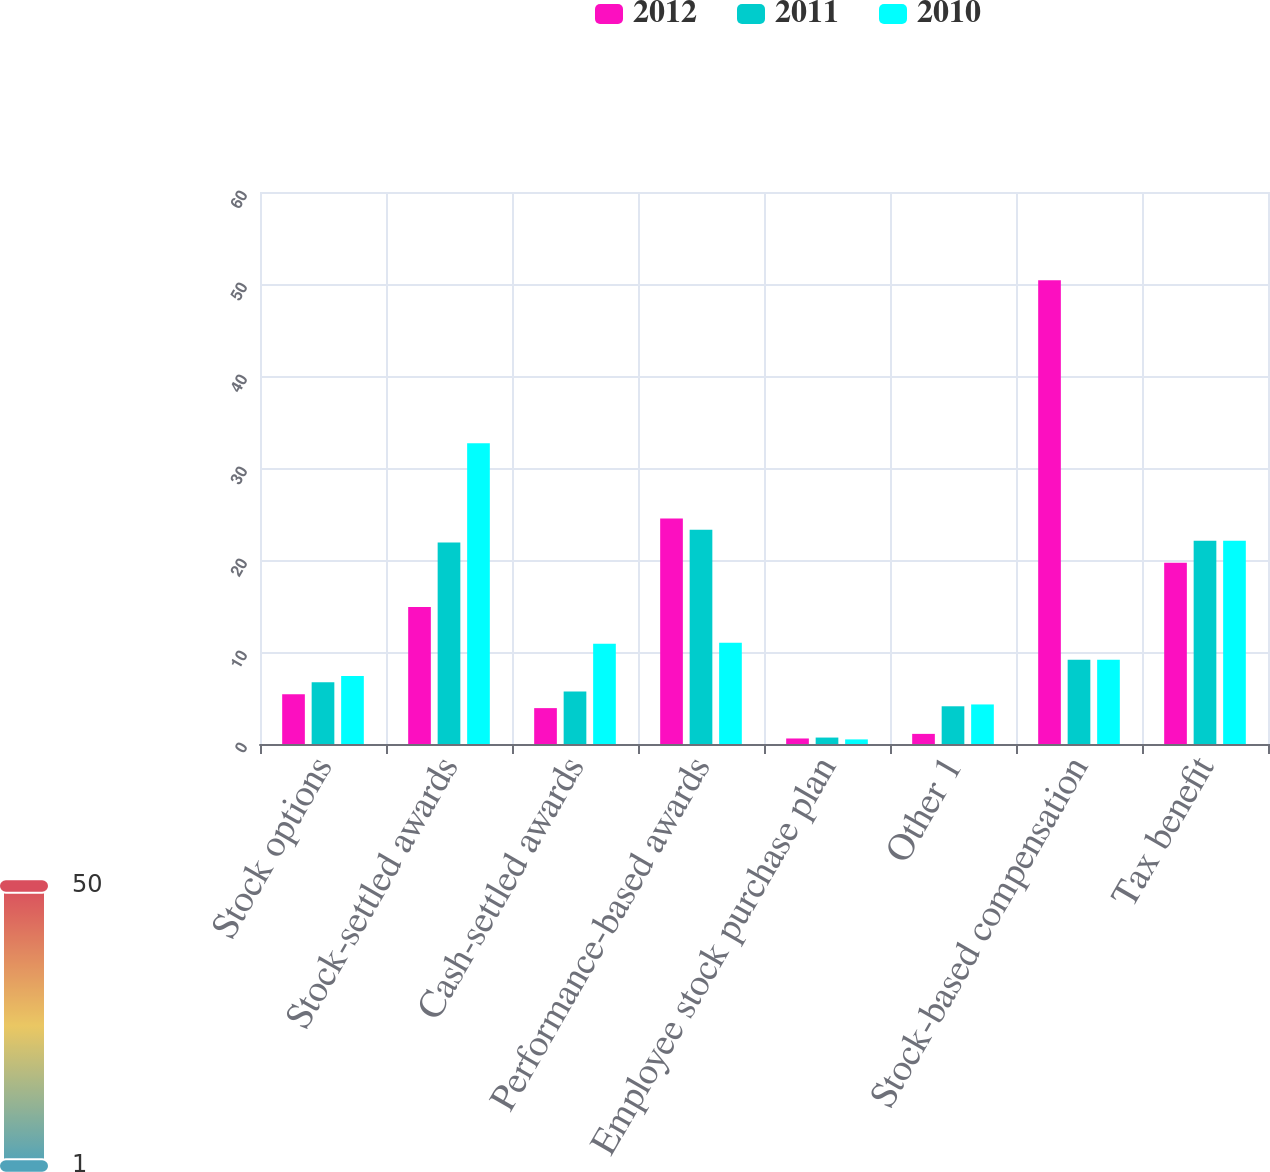<chart> <loc_0><loc_0><loc_500><loc_500><stacked_bar_chart><ecel><fcel>Stock options<fcel>Stock-settled awards<fcel>Cash-settled awards<fcel>Performance-based awards<fcel>Employee stock purchase plan<fcel>Other 1<fcel>Stock-based compensation<fcel>Tax benefit<nl><fcel>2012<fcel>5.4<fcel>14.9<fcel>3.9<fcel>24.5<fcel>0.6<fcel>1.1<fcel>50.4<fcel>19.7<nl><fcel>2011<fcel>6.7<fcel>21.9<fcel>5.7<fcel>23.3<fcel>0.7<fcel>4.1<fcel>9.15<fcel>22.1<nl><fcel>2010<fcel>7.4<fcel>32.7<fcel>10.9<fcel>11<fcel>0.5<fcel>4.3<fcel>9.15<fcel>22.1<nl></chart> 